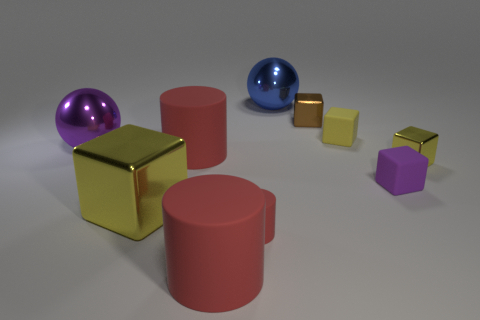Can you describe the texture of the objects? Each object appears to have a smooth and reflective texture, suggesting they are made of materials such as polished metal or plastic. The light sources cause highlights and reflections that give the objects a glossy appearance. 